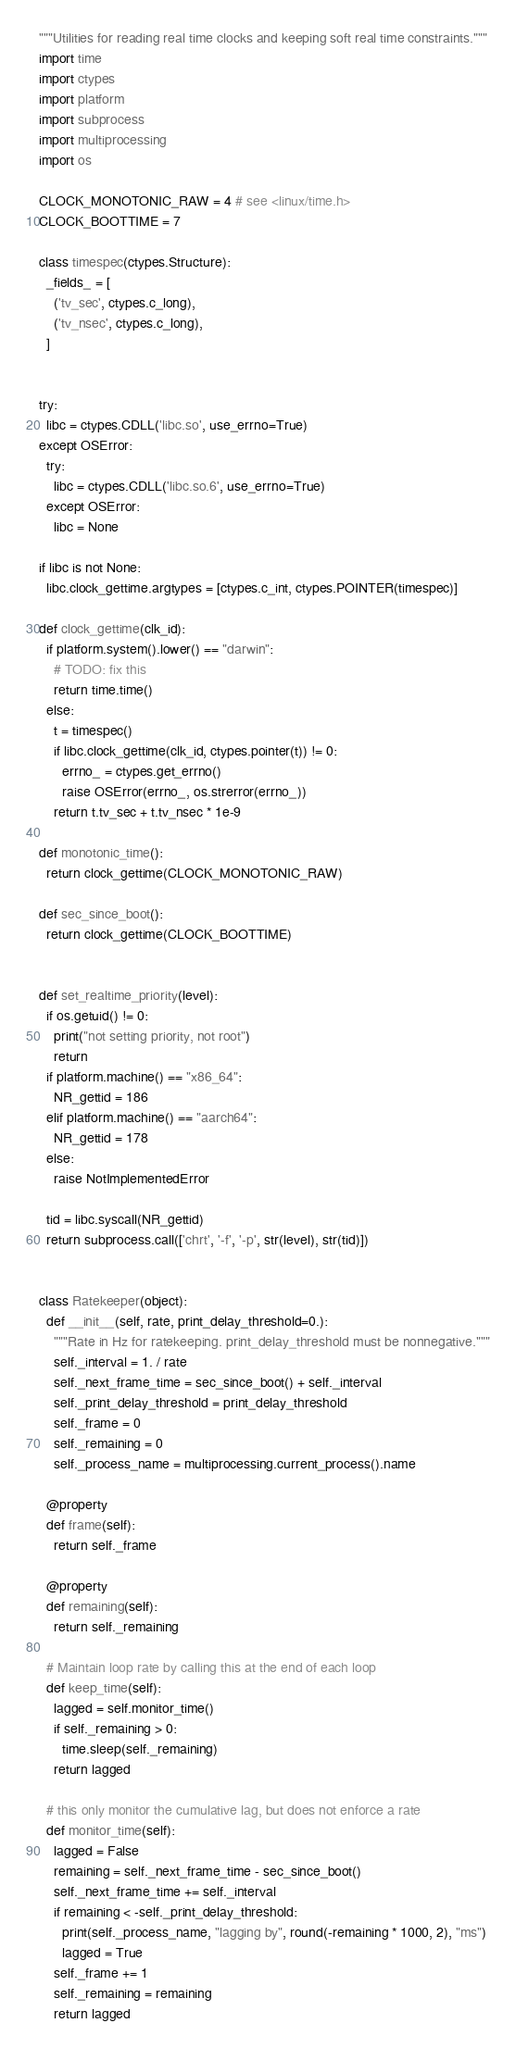<code> <loc_0><loc_0><loc_500><loc_500><_Python_>"""Utilities for reading real time clocks and keeping soft real time constraints."""
import time
import ctypes
import platform
import subprocess
import multiprocessing
import os

CLOCK_MONOTONIC_RAW = 4 # see <linux/time.h>
CLOCK_BOOTTIME = 7

class timespec(ctypes.Structure):
  _fields_ = [
    ('tv_sec', ctypes.c_long),
    ('tv_nsec', ctypes.c_long),
  ]


try:
  libc = ctypes.CDLL('libc.so', use_errno=True)
except OSError:
  try:
    libc = ctypes.CDLL('libc.so.6', use_errno=True)
  except OSError:
    libc = None

if libc is not None:
  libc.clock_gettime.argtypes = [ctypes.c_int, ctypes.POINTER(timespec)]

def clock_gettime(clk_id):
  if platform.system().lower() == "darwin":
    # TODO: fix this
    return time.time()
  else:
    t = timespec()
    if libc.clock_gettime(clk_id, ctypes.pointer(t)) != 0:
      errno_ = ctypes.get_errno()
      raise OSError(errno_, os.strerror(errno_))
    return t.tv_sec + t.tv_nsec * 1e-9

def monotonic_time():
  return clock_gettime(CLOCK_MONOTONIC_RAW)

def sec_since_boot():
  return clock_gettime(CLOCK_BOOTTIME)


def set_realtime_priority(level):
  if os.getuid() != 0:
    print("not setting priority, not root")
    return
  if platform.machine() == "x86_64":
    NR_gettid = 186
  elif platform.machine() == "aarch64":
    NR_gettid = 178
  else:
    raise NotImplementedError

  tid = libc.syscall(NR_gettid)
  return subprocess.call(['chrt', '-f', '-p', str(level), str(tid)])


class Ratekeeper(object):
  def __init__(self, rate, print_delay_threshold=0.):
    """Rate in Hz for ratekeeping. print_delay_threshold must be nonnegative."""
    self._interval = 1. / rate
    self._next_frame_time = sec_since_boot() + self._interval
    self._print_delay_threshold = print_delay_threshold
    self._frame = 0
    self._remaining = 0
    self._process_name = multiprocessing.current_process().name

  @property
  def frame(self):
    return self._frame

  @property
  def remaining(self):
    return self._remaining

  # Maintain loop rate by calling this at the end of each loop
  def keep_time(self):
    lagged = self.monitor_time()
    if self._remaining > 0:
      time.sleep(self._remaining)
    return lagged

  # this only monitor the cumulative lag, but does not enforce a rate
  def monitor_time(self):
    lagged = False
    remaining = self._next_frame_time - sec_since_boot()
    self._next_frame_time += self._interval
    if remaining < -self._print_delay_threshold:
      print(self._process_name, "lagging by", round(-remaining * 1000, 2), "ms")
      lagged = True
    self._frame += 1
    self._remaining = remaining
    return lagged
</code> 